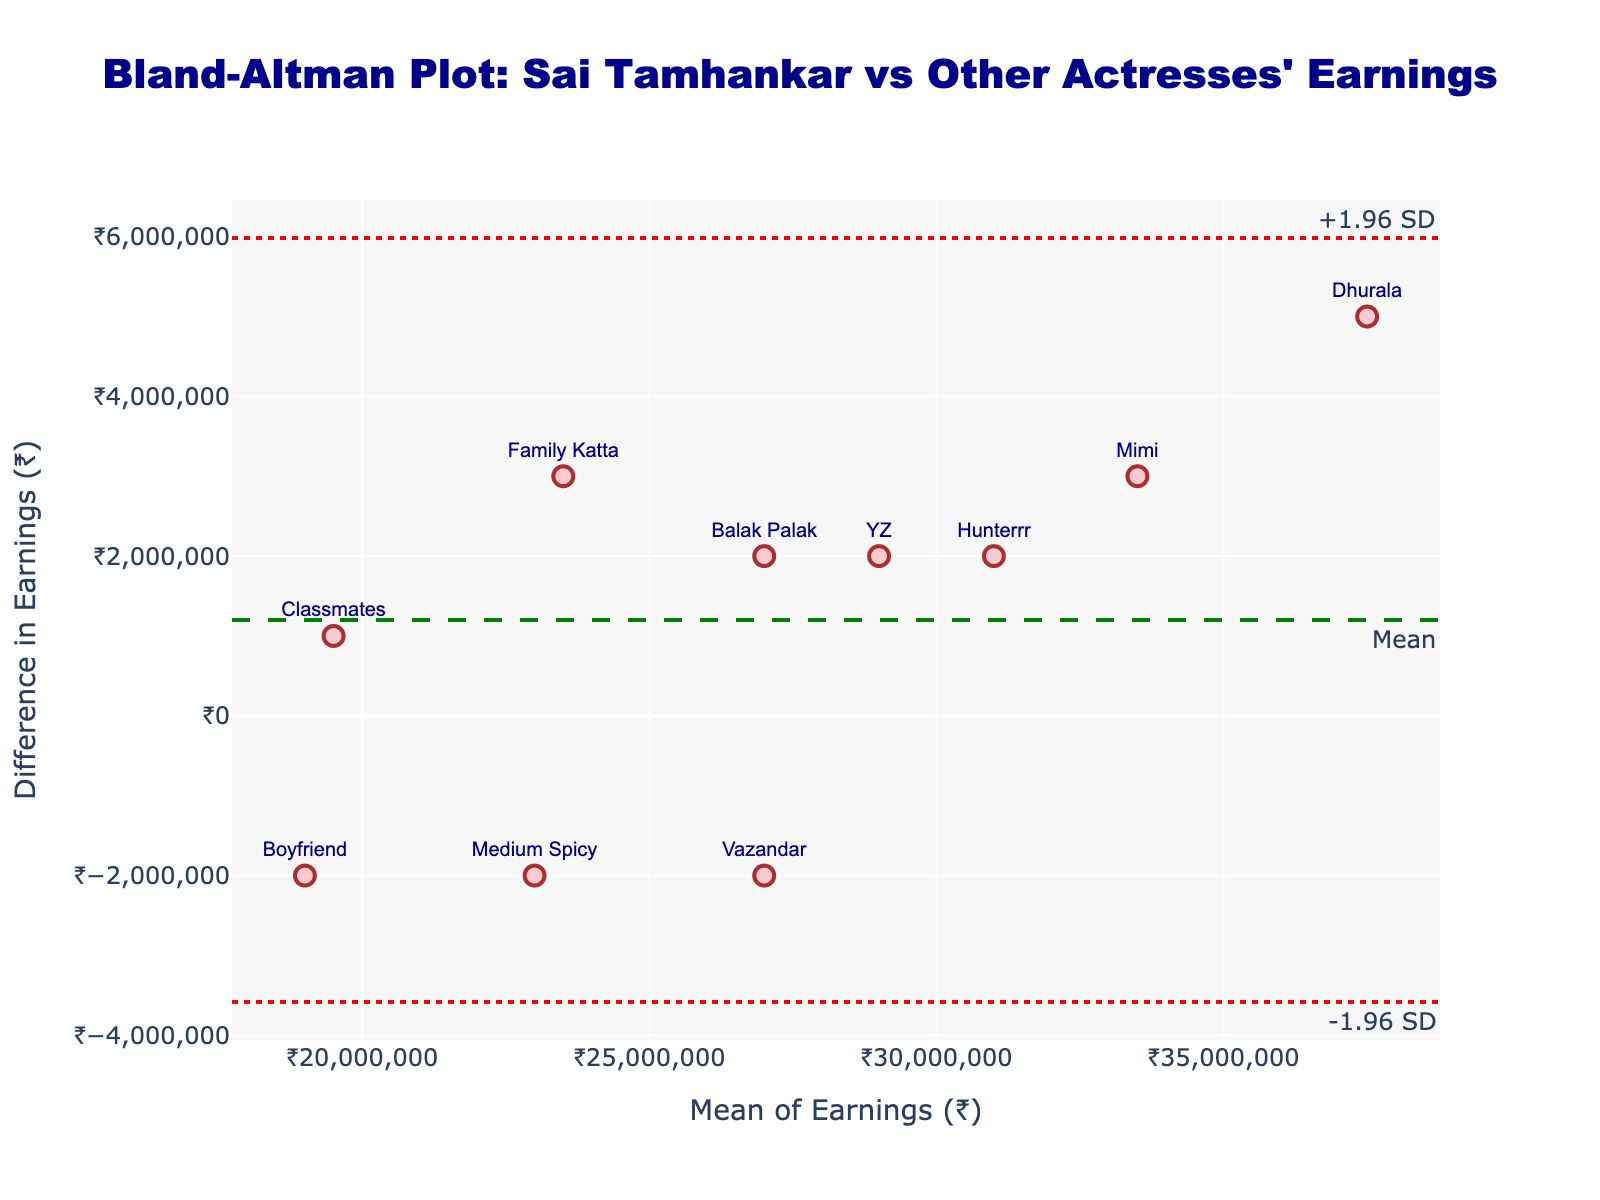What is the title of the plot? The title is usually displayed at the top of the plot. In this case, it is clearly mentioned as "Bland-Altman Plot: Sai Tamhankar vs Other Actresses' Earnings".
Answer: Bland-Altman Plot: Sai Tamhankar vs Other Actresses' Earnings What is the y-axis title of the plot? The y-axis title is located along the vertical axis of the plot. It indicates what the y-values represent, which is specified as "Difference in Earnings (₹)".
Answer: Difference in Earnings (₹) How many data points are there in the plot? Each data point is represented by a marker with a film name. By counting these markers, we can determine that there are 10 data points.
Answer: 10 What is the mean difference in earnings between Sai Tamhankar's films and other actresses' films? The mean difference is shown by a green dashed horizontal line labeled "Mean". This line is at the y-value of around ₹1,000,000.
Answer: ₹1,000,000 Which film has the highest mean earnings? By looking at the position along the x-axis, the film with the highest mean earnings is "Dhurala", which is closest to the right side of the plot.
Answer: Dhurala What is the mean of earnings for the film "YZ"? The film "YZ" is plotted at a mean earnings value on the x-axis. From its marker position, it's around ₹29,000,000.
Answer: ₹29,000,000 Are there any films where Sai Tamhankar's earnings are much lower than other actresses? The plot shows differences in earnings along the y-axis. If a marker is significantly below the horizontal axis, it indicates Sai Tamhankar earned less. "Boyfriend" is significantly below the x-axis.
Answer: Boyfriend What are the upper and lower limits of agreement in the plot? Limits of agreement are identified by red dotted horizontal lines labeled "+1.96 SD" and "-1.96 SD". These correspond to approximately ₹7,000,000 and -₹5,000,000, respectively.
Answer: ₹7,000,000 and -₹5,000,000 Between which two films is the difference in earnings the smallest? The smallest difference is indicated by the marker closest to the horizontal axis. "Classmates" is closest to the x-axis, showing the smallest difference.
Answer: Classmates Which film has a mean earnings closest to the mean difference line? The marker closest to the green dashed line (Mean) represents the film. "Classmates" is nearest to this line.
Answer: Classmates 